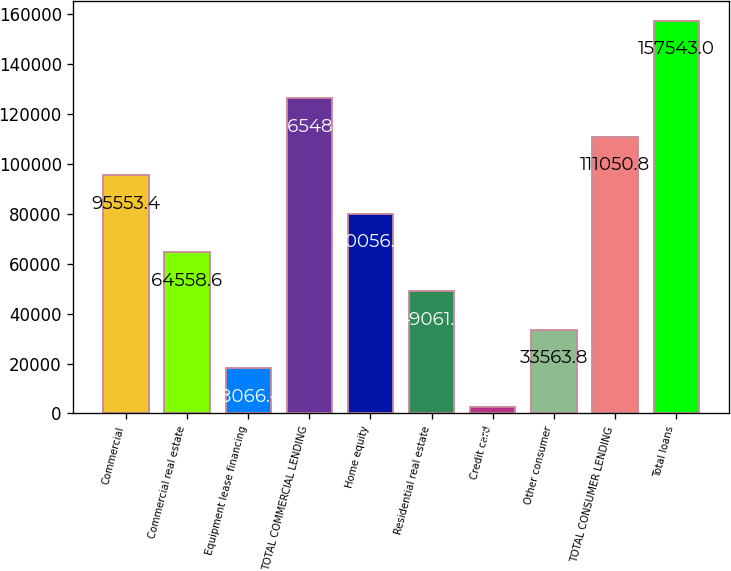Convert chart. <chart><loc_0><loc_0><loc_500><loc_500><bar_chart><fcel>Commercial<fcel>Commercial real estate<fcel>Equipment lease financing<fcel>TOTAL COMMERCIAL LENDING<fcel>Home equity<fcel>Residential real estate<fcel>Credit card<fcel>Other consumer<fcel>TOTAL CONSUMER LENDING<fcel>Total loans<nl><fcel>95553.4<fcel>64558.6<fcel>18066.4<fcel>126548<fcel>80056<fcel>49061.2<fcel>2569<fcel>33563.8<fcel>111051<fcel>157543<nl></chart> 